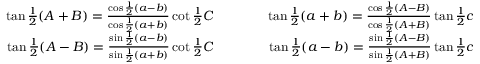Convert formula to latex. <formula><loc_0><loc_0><loc_500><loc_500>{ \begin{array} { r l r } { \tan { \frac { 1 } { 2 } } ( A + B ) = { \frac { \cos { \frac { 1 } { 2 } } ( a - b ) } { \cos { \frac { 1 } { 2 } } ( a + b ) } } \cot { \frac { 1 } { 2 } } C } & { \quad } & { \tan { \frac { 1 } { 2 } } ( a + b ) = { \frac { \cos { \frac { 1 } { 2 } } ( A - B ) } { \cos { \frac { 1 } { 2 } } ( A + B ) } } \tan { \frac { 1 } { 2 } } c } \\ { \tan { \frac { 1 } { 2 } } ( A - B ) = { \frac { \sin { \frac { 1 } { 2 } } ( a - b ) } { \sin { \frac { 1 } { 2 } } ( a + b ) } } \cot { \frac { 1 } { 2 } } C } & { \quad } & { \tan { \frac { 1 } { 2 } } ( a - b ) = { \frac { \sin { \frac { 1 } { 2 } } ( A - B ) } { \sin { \frac { 1 } { 2 } } ( A + B ) } } \tan { \frac { 1 } { 2 } } c } \end{array} }</formula> 